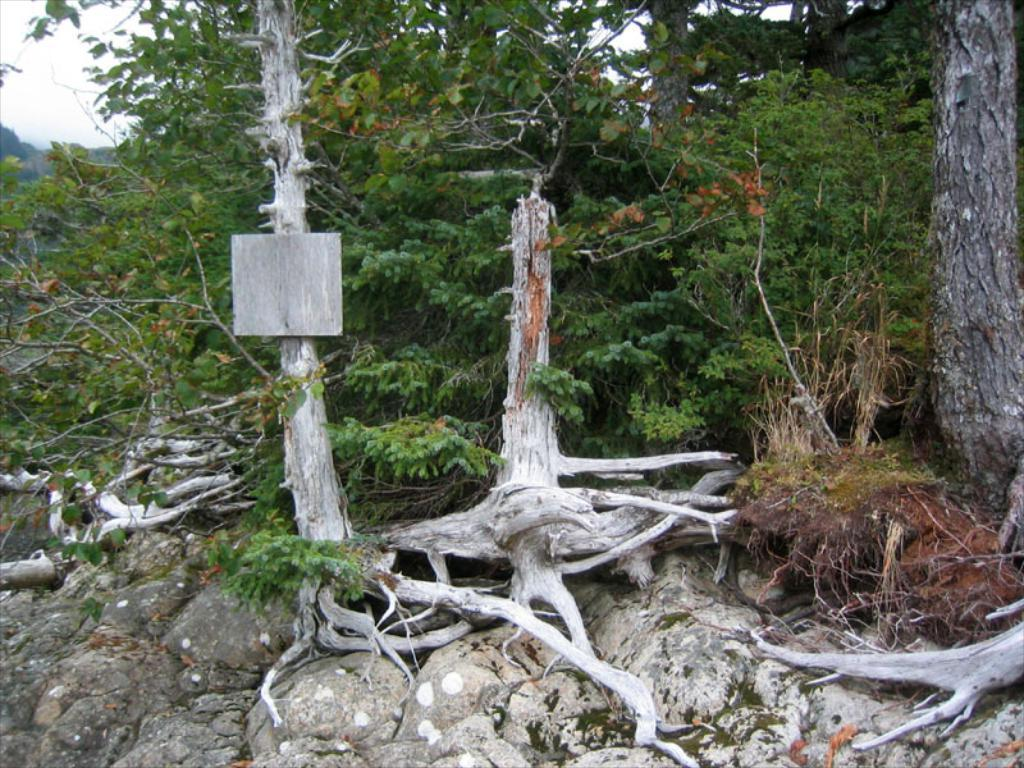What type of vegetation can be seen in the image? There are trees in the image. What part of the natural environment is visible in the image? The sky is visible in the background of the image. What type of pleasure can be seen sailing in the image? There is no pleasure or sailing depicted in the image; it features trees and the sky. 